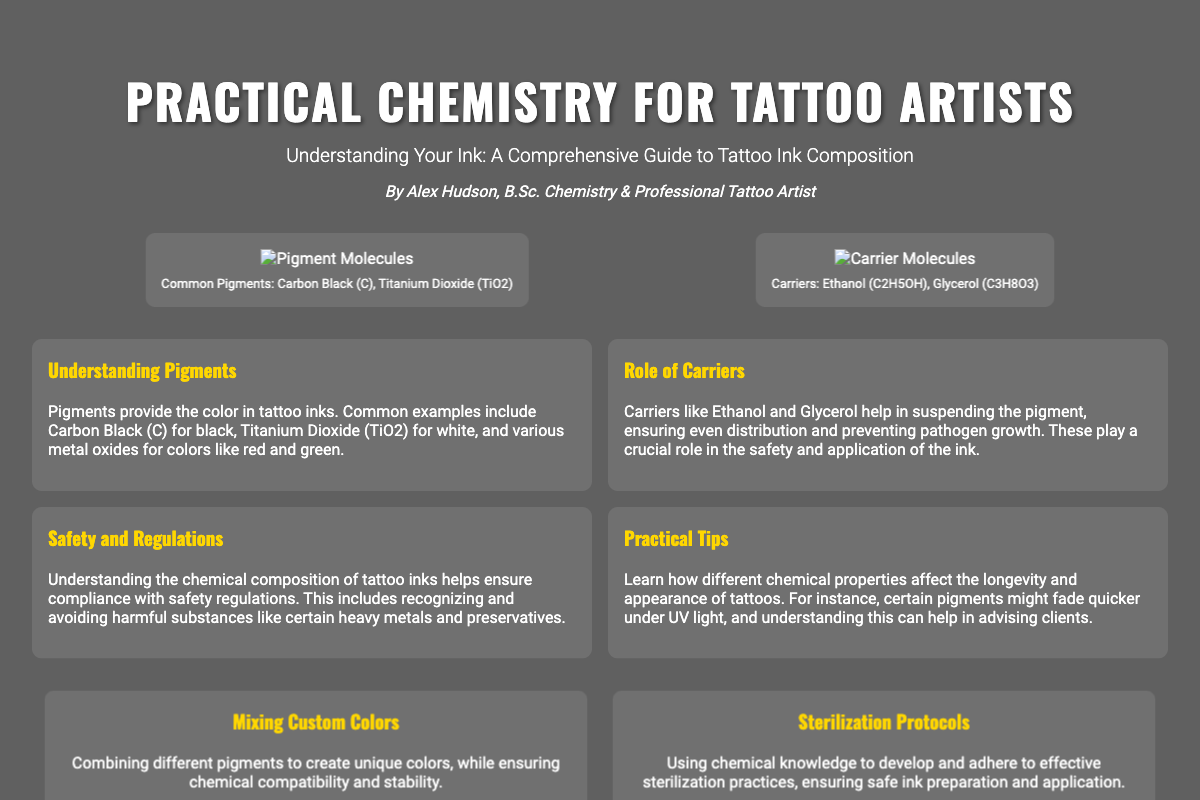What is the title of the book? The title is prominently displayed at the top of the document, indicating the main subject matter of the content.
Answer: Practical Chemistry for Tattoo Artists Who is the author of the book? The author's name is mentioned in the author section, providing information about the credentials behind the publication.
Answer: Alex Hudson What do Carbon Black and Titanium Dioxide provide in tattoo inks? This information is found in the highlights about pigments, indicating their function in tattoo composition.
Answer: Color What are examples of carrier molecules mentioned? The details about carrier molecules, their composition, and significance are outlined in the visual section and highlights.
Answer: Ethanol, Glycerol What role do carriers play in tattoo ink? Their function is explained in the highlights section related to their contribution to ink safety and application consistency.
Answer: Even distribution, preventing pathogen growth How can tattoo artists mix custom colors? The application section discusses combining pigments to create various colors, with a focus on the chemical aspect of inks.
Answer: Ensuring chemical compatibility and stability What is one practical tip mentioned regarding tattoo longevity? The highlights include practical tips about different chemical properties affecting the fading of tattoos under UV light.
Answer: Certain pigments might fade quicker under UV light What is a key focus of the safety section in the book? This relates to the safety concerns surrounding tattoo ink chemistry and regulations as mentioned in the highlights.
Answer: Compliance with safety regulations 